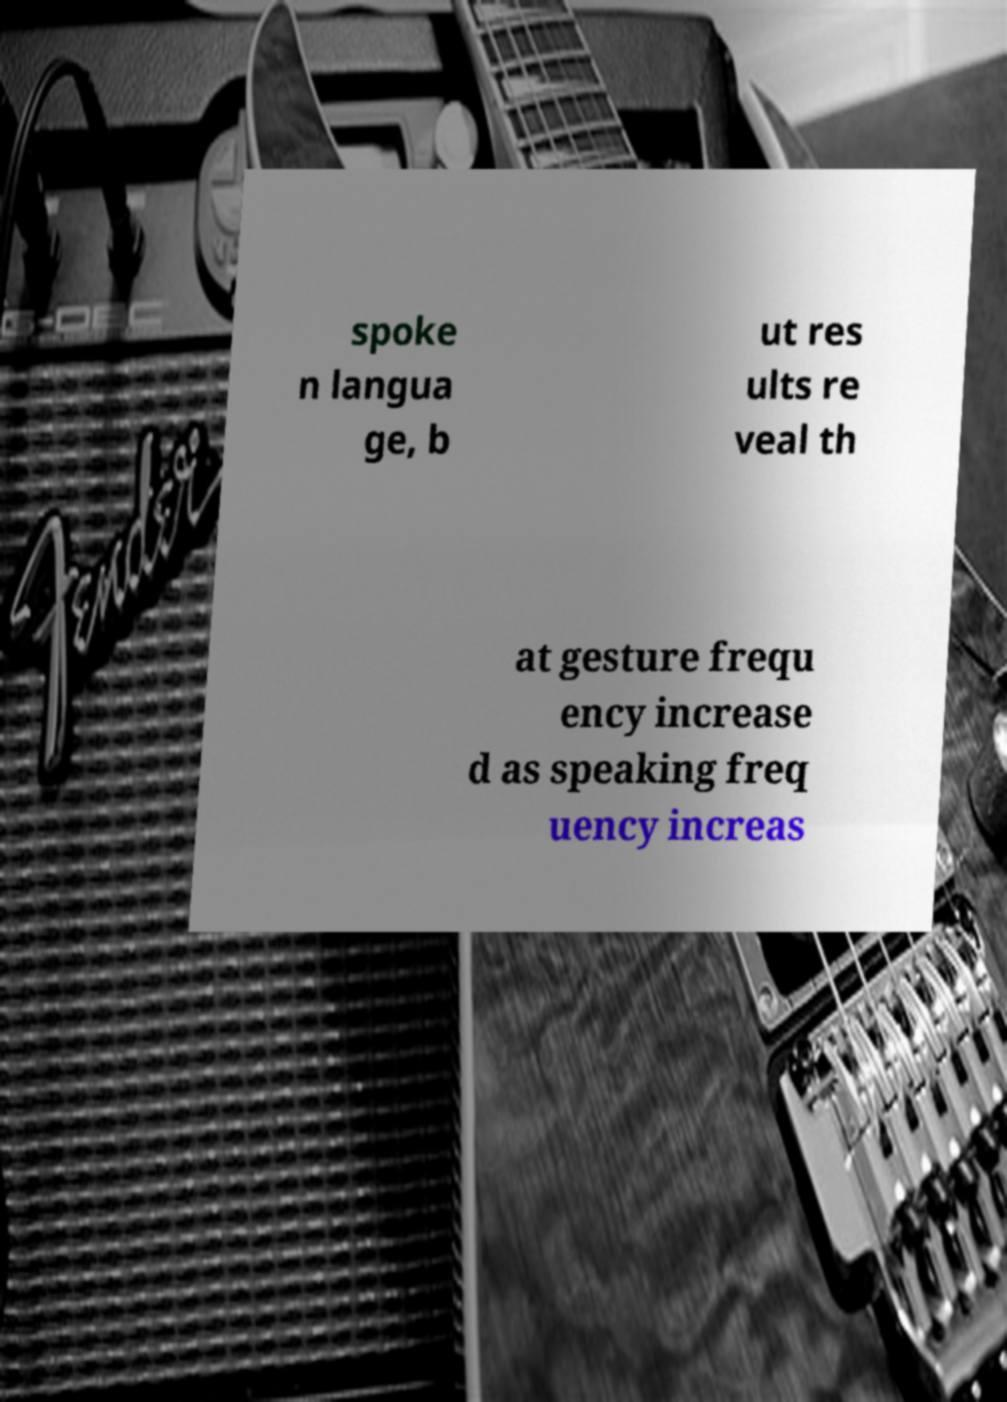Please read and relay the text visible in this image. What does it say? spoke n langua ge, b ut res ults re veal th at gesture frequ ency increase d as speaking freq uency increas 